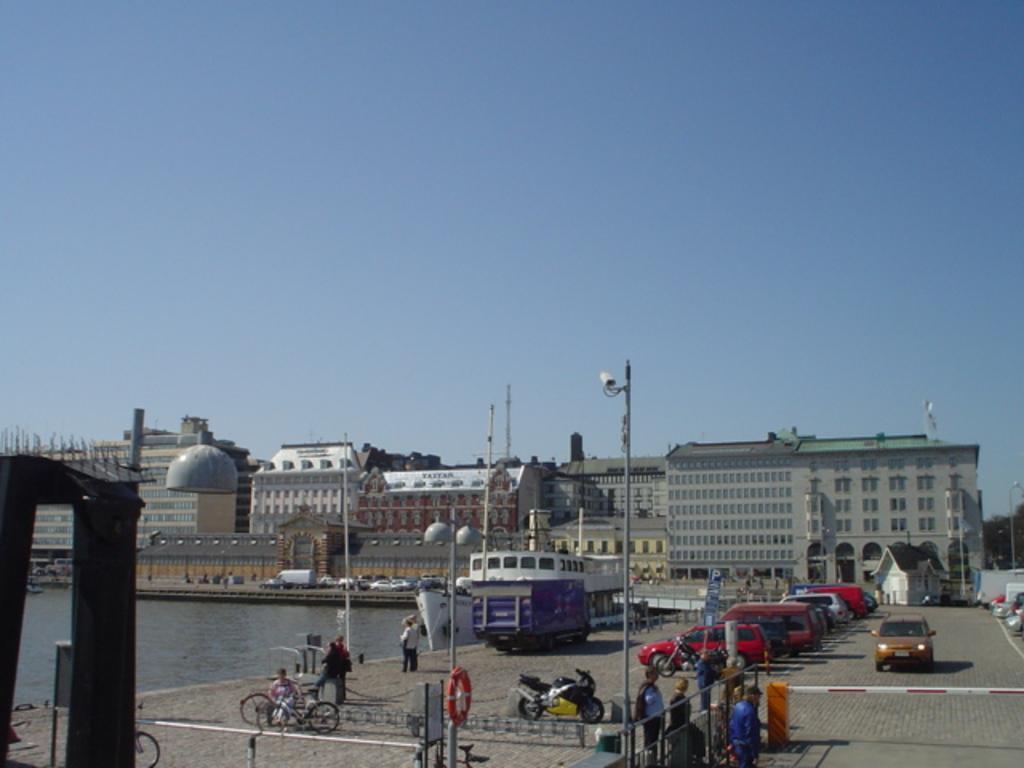In one or two sentences, can you explain what this image depicts? In this image there is the sky, there are buildings, there are vehicles, there are poles, there are bicycles, there is a river, there is a ship, there is street light, there is an object truncated towards the left of the image, there is a tree truncated towards the right of the image, there are objects truncated towards the right of the image, there are parking board, there are motorcycles, there are persons. 